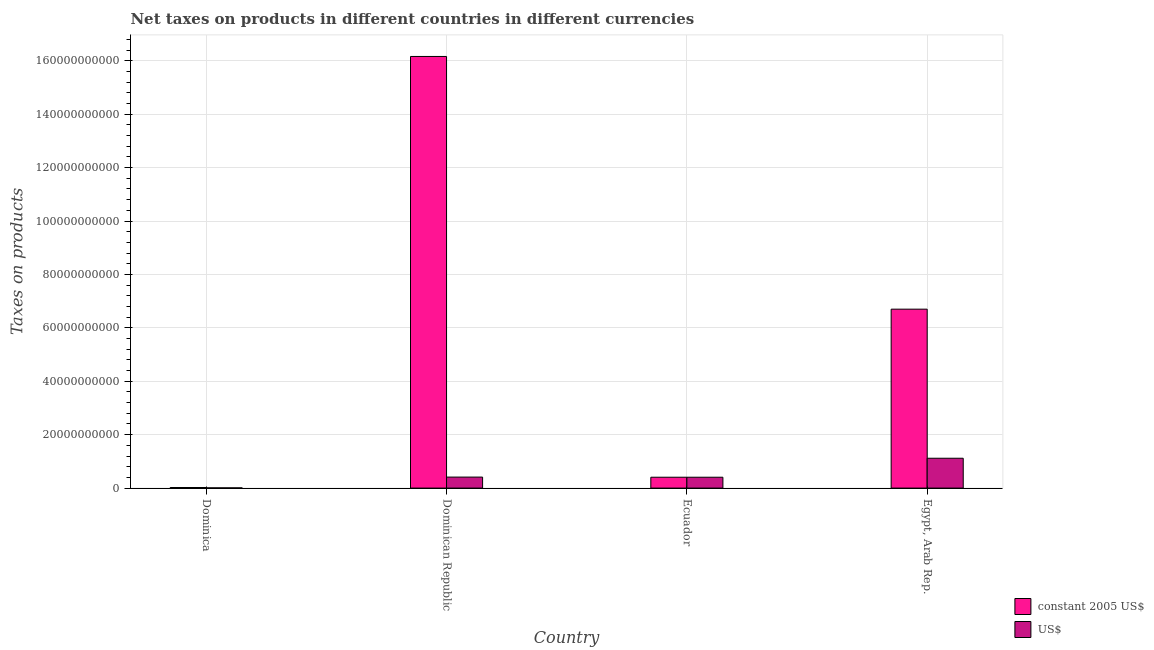How many different coloured bars are there?
Provide a short and direct response. 2. How many bars are there on the 4th tick from the right?
Your answer should be very brief. 2. What is the label of the 4th group of bars from the left?
Keep it short and to the point. Egypt, Arab Rep. What is the net taxes in constant 2005 us$ in Egypt, Arab Rep.?
Keep it short and to the point. 6.70e+1. Across all countries, what is the maximum net taxes in constant 2005 us$?
Your answer should be compact. 1.62e+11. Across all countries, what is the minimum net taxes in us$?
Your response must be concise. 8.01e+07. In which country was the net taxes in constant 2005 us$ maximum?
Your response must be concise. Dominican Republic. In which country was the net taxes in us$ minimum?
Make the answer very short. Dominica. What is the total net taxes in us$ in the graph?
Provide a succinct answer. 1.94e+1. What is the difference between the net taxes in us$ in Ecuador and that in Egypt, Arab Rep.?
Keep it short and to the point. -7.11e+09. What is the difference between the net taxes in us$ in Ecuador and the net taxes in constant 2005 us$ in Dominican Republic?
Your answer should be compact. -1.58e+11. What is the average net taxes in constant 2005 us$ per country?
Your response must be concise. 5.82e+1. What is the difference between the net taxes in constant 2005 us$ and net taxes in us$ in Dominica?
Your answer should be very brief. 1.36e+08. In how many countries, is the net taxes in us$ greater than 60000000000 units?
Your answer should be compact. 0. What is the ratio of the net taxes in us$ in Dominican Republic to that in Egypt, Arab Rep.?
Offer a terse response. 0.37. What is the difference between the highest and the second highest net taxes in us$?
Offer a terse response. 7.06e+09. What is the difference between the highest and the lowest net taxes in us$?
Offer a very short reply. 1.11e+1. Is the sum of the net taxes in constant 2005 us$ in Ecuador and Egypt, Arab Rep. greater than the maximum net taxes in us$ across all countries?
Make the answer very short. Yes. What does the 1st bar from the left in Egypt, Arab Rep. represents?
Your response must be concise. Constant 2005 us$. What does the 2nd bar from the right in Dominican Republic represents?
Your answer should be very brief. Constant 2005 us$. What is the difference between two consecutive major ticks on the Y-axis?
Your answer should be compact. 2.00e+1. Are the values on the major ticks of Y-axis written in scientific E-notation?
Offer a very short reply. No. How many legend labels are there?
Keep it short and to the point. 2. What is the title of the graph?
Your answer should be very brief. Net taxes on products in different countries in different currencies. What is the label or title of the Y-axis?
Provide a short and direct response. Taxes on products. What is the Taxes on products of constant 2005 US$ in Dominica?
Provide a succinct answer. 2.16e+08. What is the Taxes on products of US$ in Dominica?
Provide a succinct answer. 8.01e+07. What is the Taxes on products of constant 2005 US$ in Dominican Republic?
Offer a very short reply. 1.62e+11. What is the Taxes on products in US$ in Dominican Republic?
Your response must be concise. 4.12e+09. What is the Taxes on products in constant 2005 US$ in Ecuador?
Offer a terse response. 4.07e+09. What is the Taxes on products in US$ in Ecuador?
Provide a succinct answer. 4.07e+09. What is the Taxes on products in constant 2005 US$ in Egypt, Arab Rep.?
Ensure brevity in your answer.  6.70e+1. What is the Taxes on products of US$ in Egypt, Arab Rep.?
Keep it short and to the point. 1.12e+1. Across all countries, what is the maximum Taxes on products in constant 2005 US$?
Keep it short and to the point. 1.62e+11. Across all countries, what is the maximum Taxes on products of US$?
Ensure brevity in your answer.  1.12e+1. Across all countries, what is the minimum Taxes on products of constant 2005 US$?
Provide a short and direct response. 2.16e+08. Across all countries, what is the minimum Taxes on products of US$?
Provide a short and direct response. 8.01e+07. What is the total Taxes on products of constant 2005 US$ in the graph?
Keep it short and to the point. 2.33e+11. What is the total Taxes on products in US$ in the graph?
Provide a succinct answer. 1.94e+1. What is the difference between the Taxes on products in constant 2005 US$ in Dominica and that in Dominican Republic?
Offer a very short reply. -1.61e+11. What is the difference between the Taxes on products in US$ in Dominica and that in Dominican Republic?
Provide a short and direct response. -4.04e+09. What is the difference between the Taxes on products in constant 2005 US$ in Dominica and that in Ecuador?
Your answer should be compact. -3.85e+09. What is the difference between the Taxes on products of US$ in Dominica and that in Ecuador?
Give a very brief answer. -3.99e+09. What is the difference between the Taxes on products of constant 2005 US$ in Dominica and that in Egypt, Arab Rep.?
Your answer should be compact. -6.68e+1. What is the difference between the Taxes on products of US$ in Dominica and that in Egypt, Arab Rep.?
Your answer should be compact. -1.11e+1. What is the difference between the Taxes on products in constant 2005 US$ in Dominican Republic and that in Ecuador?
Offer a very short reply. 1.58e+11. What is the difference between the Taxes on products in US$ in Dominican Republic and that in Ecuador?
Keep it short and to the point. 5.11e+07. What is the difference between the Taxes on products of constant 2005 US$ in Dominican Republic and that in Egypt, Arab Rep.?
Keep it short and to the point. 9.46e+1. What is the difference between the Taxes on products in US$ in Dominican Republic and that in Egypt, Arab Rep.?
Give a very brief answer. -7.06e+09. What is the difference between the Taxes on products in constant 2005 US$ in Ecuador and that in Egypt, Arab Rep.?
Provide a short and direct response. -6.29e+1. What is the difference between the Taxes on products in US$ in Ecuador and that in Egypt, Arab Rep.?
Offer a very short reply. -7.11e+09. What is the difference between the Taxes on products of constant 2005 US$ in Dominica and the Taxes on products of US$ in Dominican Republic?
Give a very brief answer. -3.90e+09. What is the difference between the Taxes on products of constant 2005 US$ in Dominica and the Taxes on products of US$ in Ecuador?
Provide a succinct answer. -3.85e+09. What is the difference between the Taxes on products of constant 2005 US$ in Dominica and the Taxes on products of US$ in Egypt, Arab Rep.?
Ensure brevity in your answer.  -1.10e+1. What is the difference between the Taxes on products in constant 2005 US$ in Dominican Republic and the Taxes on products in US$ in Ecuador?
Your response must be concise. 1.58e+11. What is the difference between the Taxes on products in constant 2005 US$ in Dominican Republic and the Taxes on products in US$ in Egypt, Arab Rep.?
Give a very brief answer. 1.50e+11. What is the difference between the Taxes on products of constant 2005 US$ in Ecuador and the Taxes on products of US$ in Egypt, Arab Rep.?
Your answer should be very brief. -7.11e+09. What is the average Taxes on products in constant 2005 US$ per country?
Provide a succinct answer. 5.82e+1. What is the average Taxes on products in US$ per country?
Ensure brevity in your answer.  4.86e+09. What is the difference between the Taxes on products of constant 2005 US$ and Taxes on products of US$ in Dominica?
Provide a short and direct response. 1.36e+08. What is the difference between the Taxes on products of constant 2005 US$ and Taxes on products of US$ in Dominican Republic?
Make the answer very short. 1.58e+11. What is the difference between the Taxes on products of constant 2005 US$ and Taxes on products of US$ in Ecuador?
Offer a terse response. 0. What is the difference between the Taxes on products of constant 2005 US$ and Taxes on products of US$ in Egypt, Arab Rep.?
Provide a short and direct response. 5.58e+1. What is the ratio of the Taxes on products of constant 2005 US$ in Dominica to that in Dominican Republic?
Make the answer very short. 0. What is the ratio of the Taxes on products in US$ in Dominica to that in Dominican Republic?
Ensure brevity in your answer.  0.02. What is the ratio of the Taxes on products of constant 2005 US$ in Dominica to that in Ecuador?
Make the answer very short. 0.05. What is the ratio of the Taxes on products of US$ in Dominica to that in Ecuador?
Your response must be concise. 0.02. What is the ratio of the Taxes on products of constant 2005 US$ in Dominica to that in Egypt, Arab Rep.?
Offer a very short reply. 0. What is the ratio of the Taxes on products of US$ in Dominica to that in Egypt, Arab Rep.?
Your answer should be very brief. 0.01. What is the ratio of the Taxes on products in constant 2005 US$ in Dominican Republic to that in Ecuador?
Provide a succinct answer. 39.73. What is the ratio of the Taxes on products in US$ in Dominican Republic to that in Ecuador?
Ensure brevity in your answer.  1.01. What is the ratio of the Taxes on products in constant 2005 US$ in Dominican Republic to that in Egypt, Arab Rep.?
Your answer should be compact. 2.41. What is the ratio of the Taxes on products of US$ in Dominican Republic to that in Egypt, Arab Rep.?
Ensure brevity in your answer.  0.37. What is the ratio of the Taxes on products of constant 2005 US$ in Ecuador to that in Egypt, Arab Rep.?
Your answer should be very brief. 0.06. What is the ratio of the Taxes on products of US$ in Ecuador to that in Egypt, Arab Rep.?
Your answer should be compact. 0.36. What is the difference between the highest and the second highest Taxes on products of constant 2005 US$?
Give a very brief answer. 9.46e+1. What is the difference between the highest and the second highest Taxes on products in US$?
Provide a succinct answer. 7.06e+09. What is the difference between the highest and the lowest Taxes on products in constant 2005 US$?
Keep it short and to the point. 1.61e+11. What is the difference between the highest and the lowest Taxes on products of US$?
Your answer should be compact. 1.11e+1. 